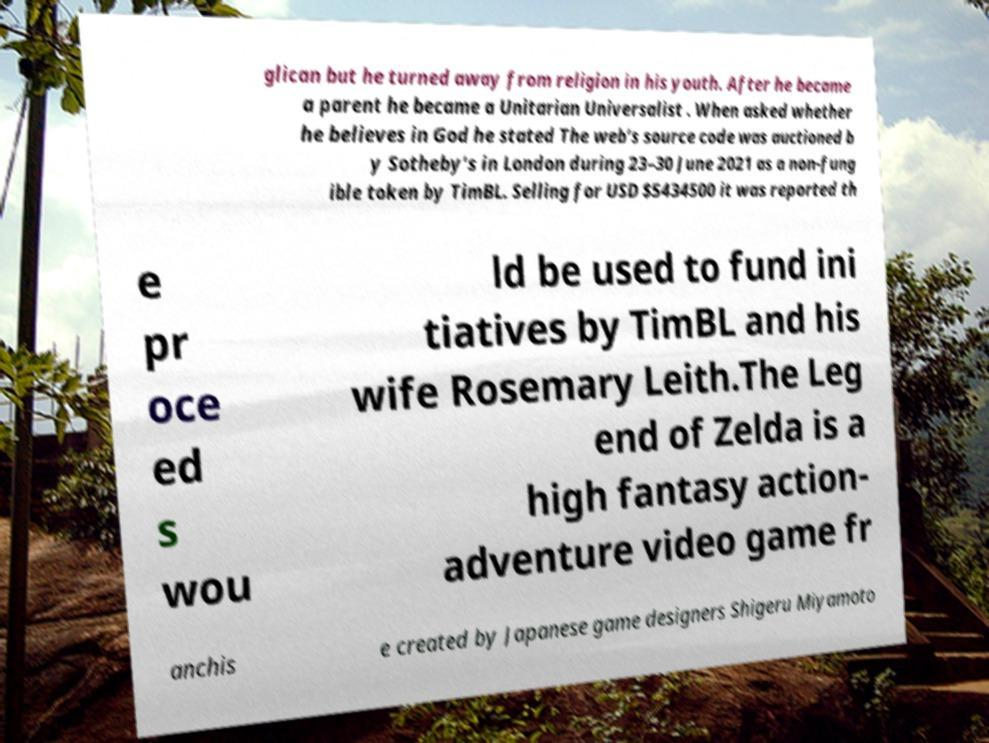Can you accurately transcribe the text from the provided image for me? glican but he turned away from religion in his youth. After he became a parent he became a Unitarian Universalist . When asked whether he believes in God he stated The web’s source code was auctioned b y Sotheby’s in London during 23–30 June 2021 as a non-fung ible token by TimBL. Selling for USD $5434500 it was reported th e pr oce ed s wou ld be used to fund ini tiatives by TimBL and his wife Rosemary Leith.The Leg end of Zelda is a high fantasy action- adventure video game fr anchis e created by Japanese game designers Shigeru Miyamoto 